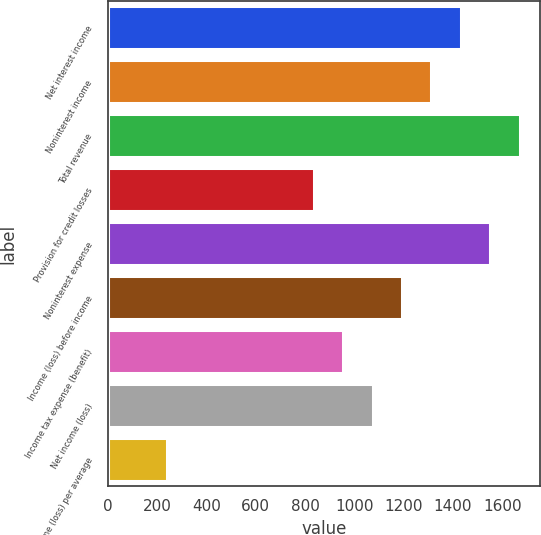Convert chart to OTSL. <chart><loc_0><loc_0><loc_500><loc_500><bar_chart><fcel>Net interest income<fcel>Noninterest income<fcel>Total revenue<fcel>Provision for credit losses<fcel>Noninterest expense<fcel>Income (loss) before income<fcel>Income tax expense (benefit)<fcel>Net income (loss)<fcel>Net income (loss) per average<nl><fcel>1431.55<fcel>1312.26<fcel>1670.13<fcel>835.1<fcel>1550.84<fcel>1192.97<fcel>954.39<fcel>1073.68<fcel>238.65<nl></chart> 